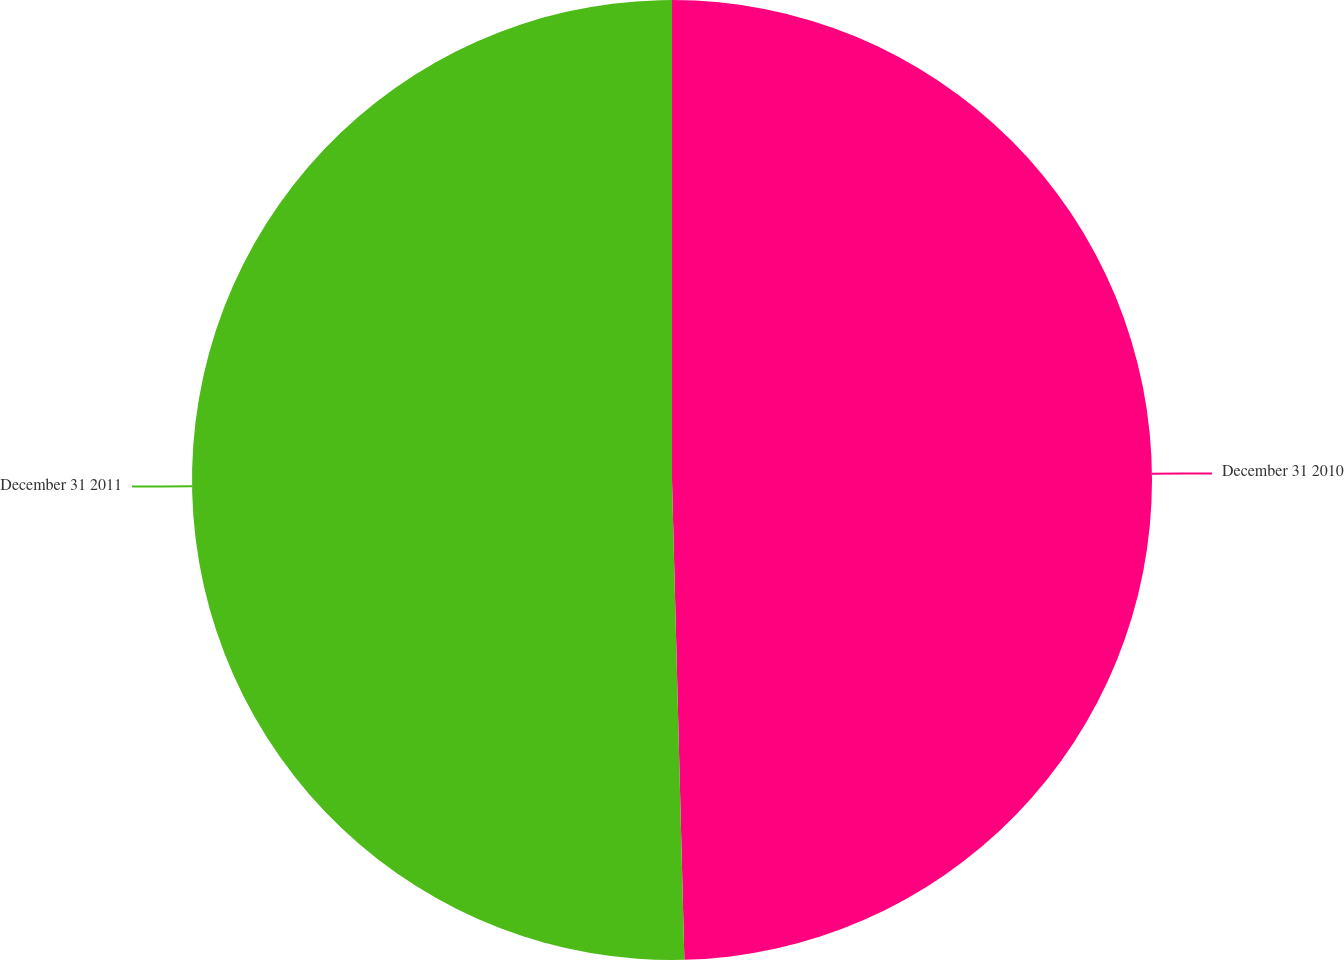Convert chart to OTSL. <chart><loc_0><loc_0><loc_500><loc_500><pie_chart><fcel>December 31 2010<fcel>December 31 2011<nl><fcel>49.59%<fcel>50.41%<nl></chart> 